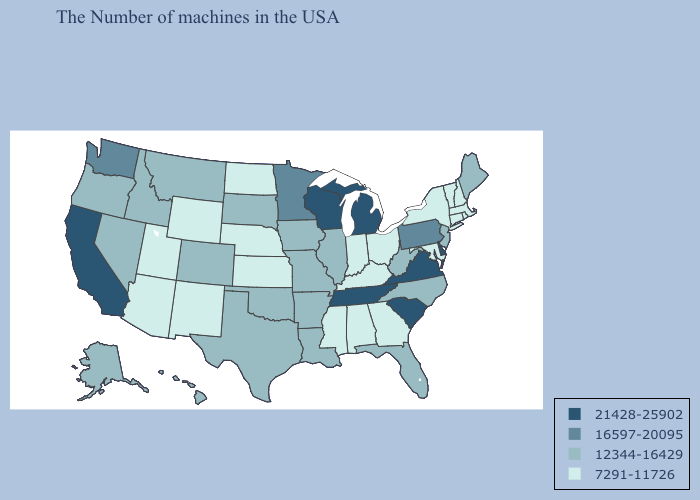Name the states that have a value in the range 7291-11726?
Write a very short answer. Massachusetts, Rhode Island, New Hampshire, Vermont, Connecticut, New York, Maryland, Ohio, Georgia, Kentucky, Indiana, Alabama, Mississippi, Kansas, Nebraska, North Dakota, Wyoming, New Mexico, Utah, Arizona. Does Oklahoma have a higher value than Missouri?
Answer briefly. No. Which states have the lowest value in the USA?
Short answer required. Massachusetts, Rhode Island, New Hampshire, Vermont, Connecticut, New York, Maryland, Ohio, Georgia, Kentucky, Indiana, Alabama, Mississippi, Kansas, Nebraska, North Dakota, Wyoming, New Mexico, Utah, Arizona. What is the highest value in the South ?
Write a very short answer. 21428-25902. Does Florida have the same value as Missouri?
Answer briefly. Yes. What is the lowest value in states that border Nevada?
Answer briefly. 7291-11726. What is the value of Oregon?
Short answer required. 12344-16429. Name the states that have a value in the range 21428-25902?
Be succinct. Delaware, Virginia, South Carolina, Michigan, Tennessee, Wisconsin, California. What is the value of Rhode Island?
Answer briefly. 7291-11726. What is the lowest value in the South?
Answer briefly. 7291-11726. What is the value of Maine?
Be succinct. 12344-16429. What is the value of Florida?
Be succinct. 12344-16429. What is the value of Wisconsin?
Write a very short answer. 21428-25902. Does Delaware have the lowest value in the USA?
Short answer required. No. Which states hav the highest value in the West?
Quick response, please. California. 